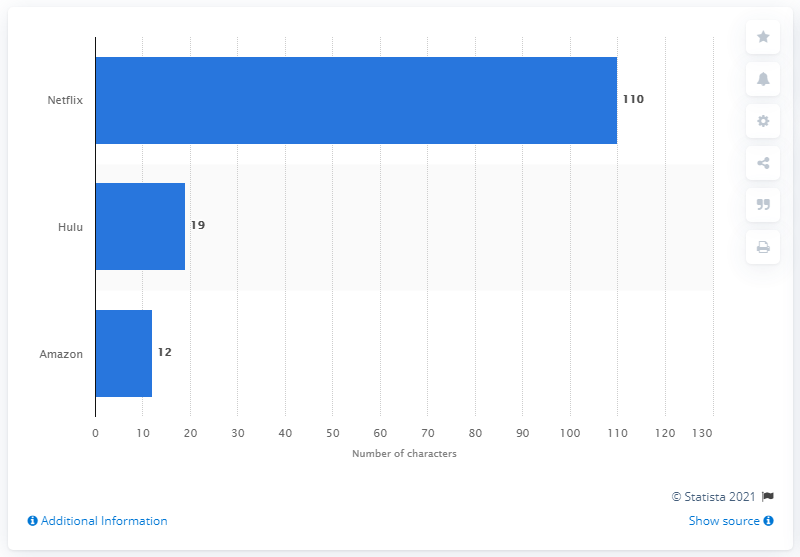Specify some key components in this picture. Netflix had 110 LGBTQ characters in the 2020-2021 season. 